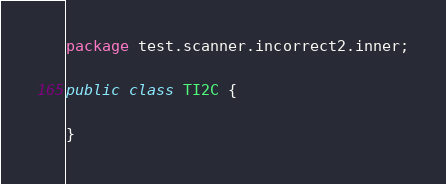<code> <loc_0><loc_0><loc_500><loc_500><_Java_>package test.scanner.incorrect2.inner;

public class TI2C {

}
</code> 